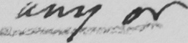Can you tell me what this handwritten text says? any or 